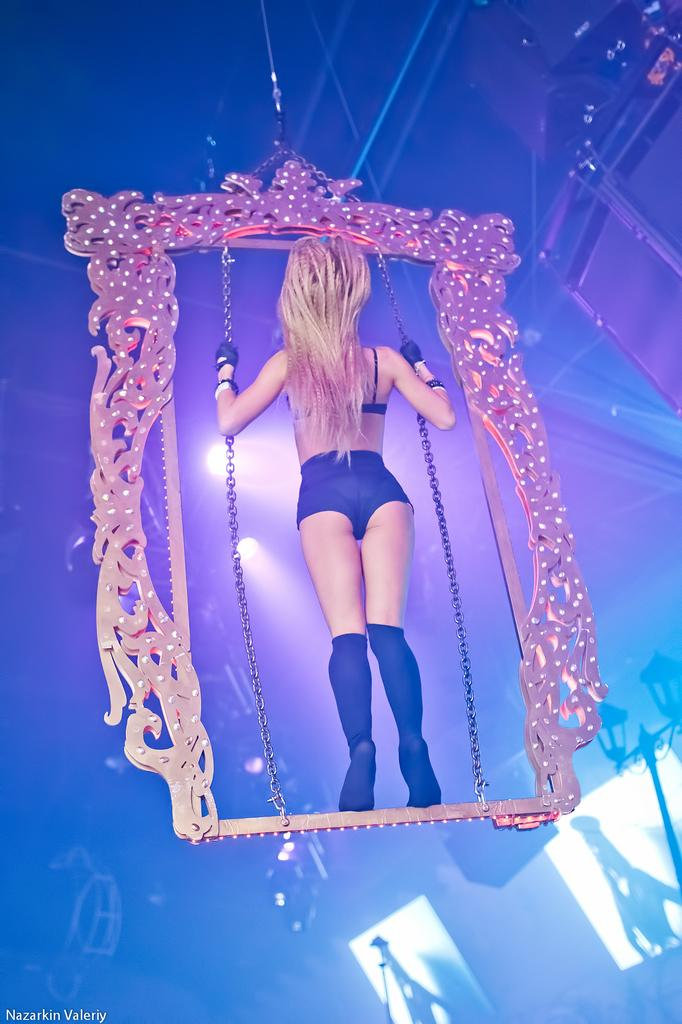Who is the main subject in the image? There is a girl in the image. What is the girl standing on? The girl is standing on a metal structure. What is the girl holding in her hands? The girl is holding chains. How is the metal structure suspended in the image? The metal structure is hanging from the top of the ceiling. What type of mint can be seen growing on the girl's shoulder in the image? There is no mint visible on the girl's shoulder in the image. How does the girl's cough affect her ability to hold the chains in the image? There is no mention of the girl coughing in the image, so it cannot be determined how it would affect her ability to hold the chains. 